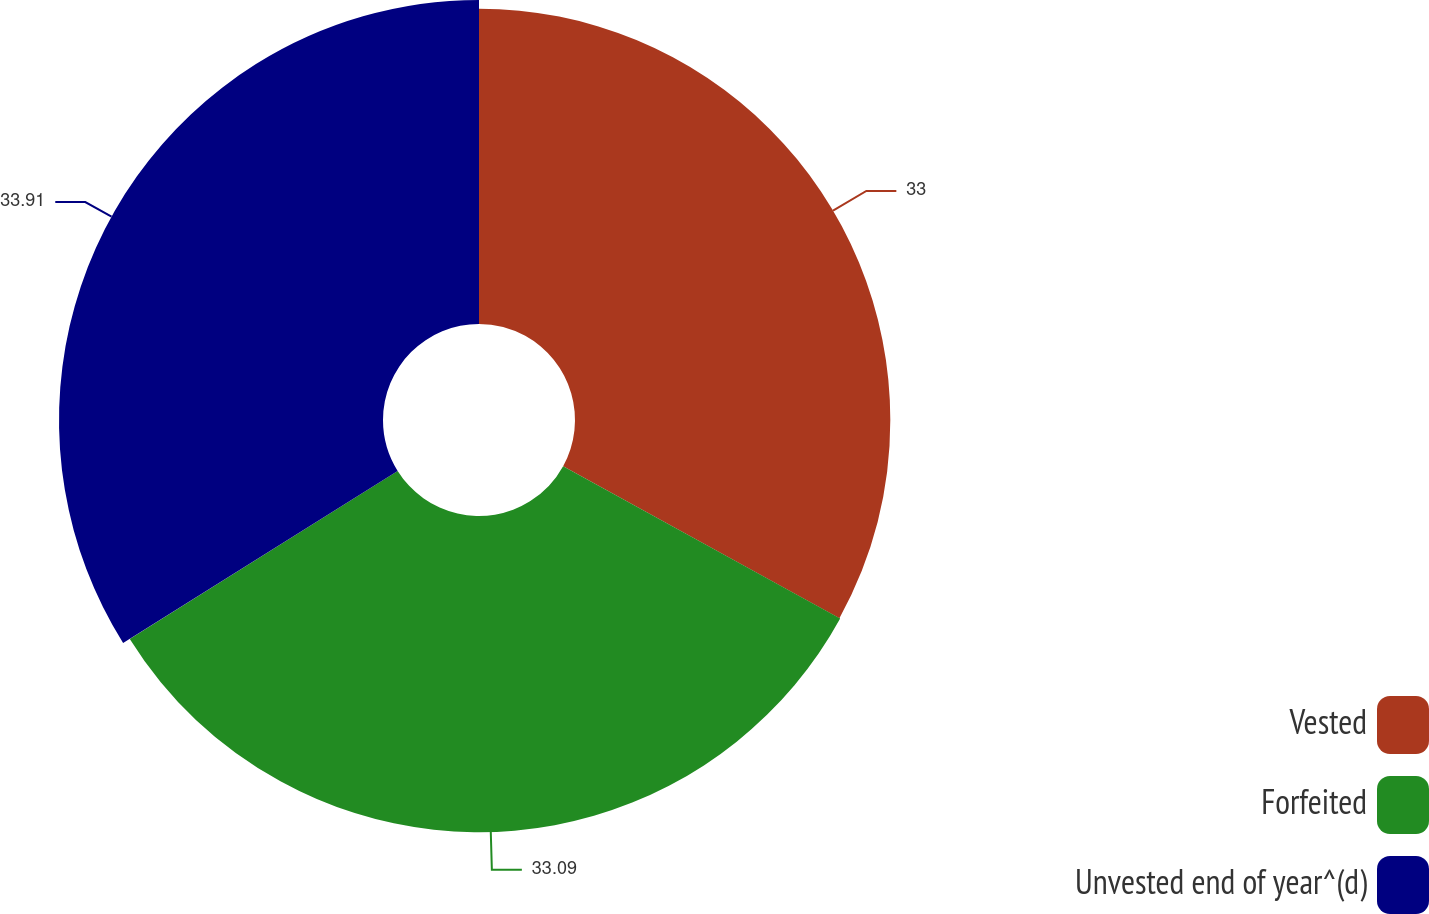Convert chart. <chart><loc_0><loc_0><loc_500><loc_500><pie_chart><fcel>Vested<fcel>Forfeited<fcel>Unvested end of year^(d)<nl><fcel>33.0%<fcel>33.09%<fcel>33.91%<nl></chart> 